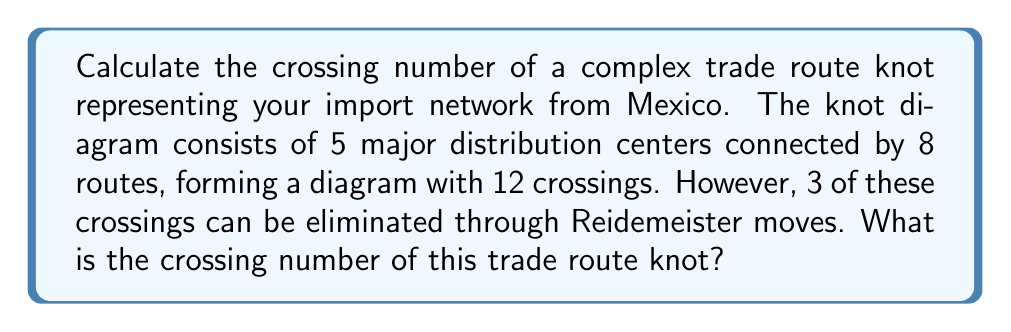Solve this math problem. To calculate the crossing number of this trade route knot, we need to follow these steps:

1. Identify the initial number of crossings in the given knot diagram:
   Initial crossings = 12

2. Determine the number of crossings that can be eliminated:
   Eliminable crossings = 3

3. Calculate the crossing number by subtracting the eliminable crossings from the initial crossings:
   
   $$\text{Crossing Number} = \text{Initial Crossings} - \text{Eliminable Crossings}$$
   $$\text{Crossing Number} = 12 - 3 = 9$$

The crossing number is the minimum number of crossings that a knot can have in any of its diagrams. In this case, after applying Reidemeister moves to eliminate the 3 unnecessary crossings, we are left with 9 crossings that cannot be further reduced.

This crossing number represents the complexity of your import network from Mexico, with each crossing potentially indicating a point where trade routes intersect or where logistics become more complicated.
Answer: 9 